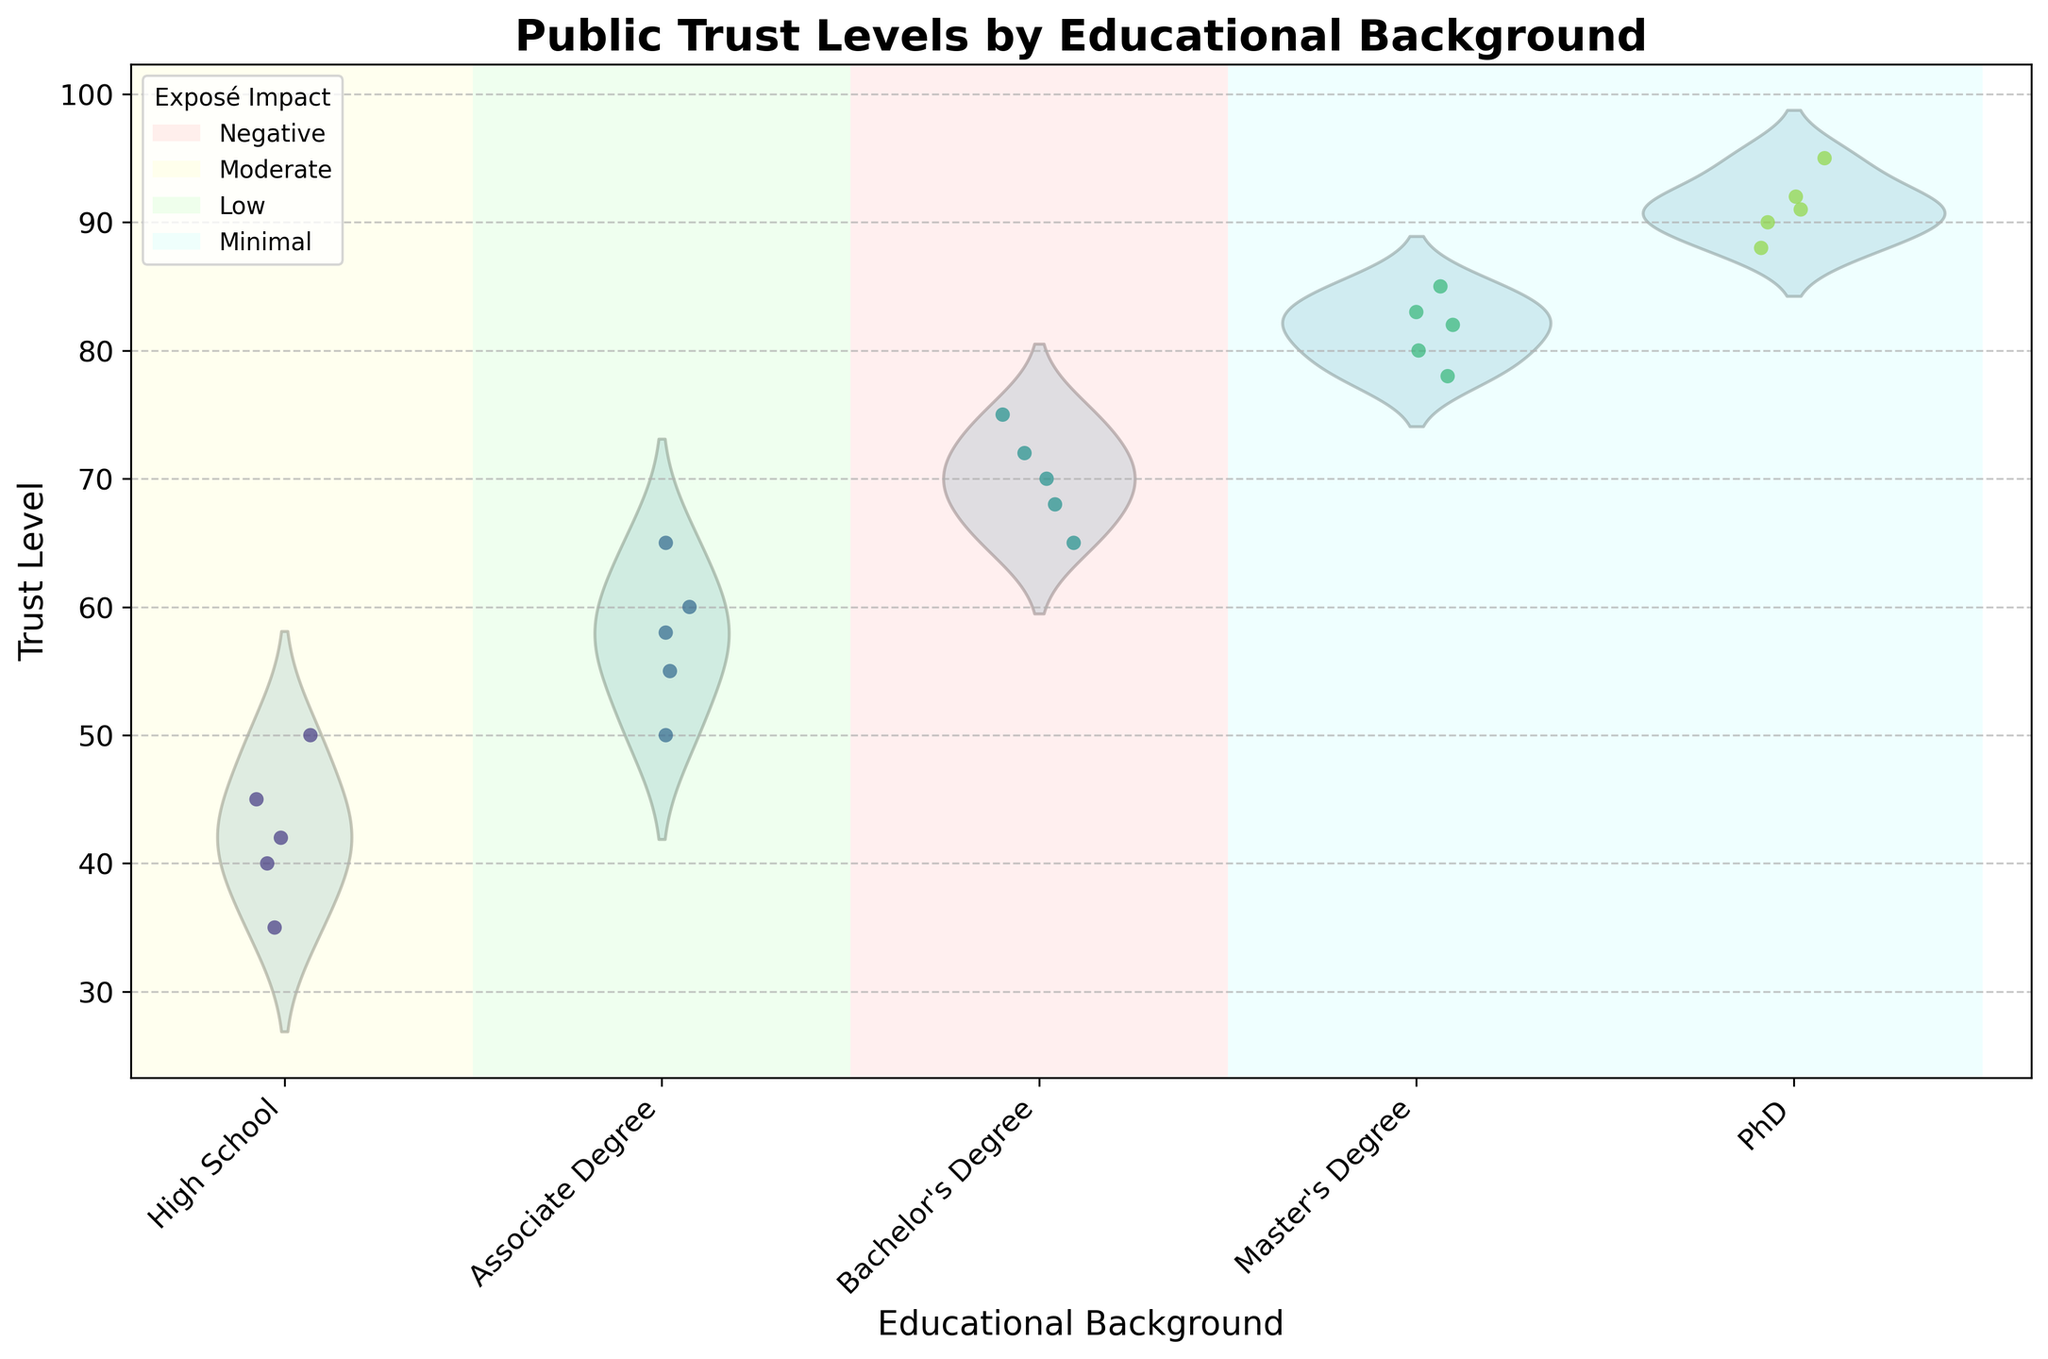What's the title of the plot? The title is shown at the top of the plot, which is "Public Trust Levels by Educational Background".
Answer: Public Trust Levels by Educational Background How many educational backgrounds are compared in the plot? The x-axis has labels for five educational backgrounds, which are "High School", "Associate Degree", "Bachelor's Degree", "Master's Degree", and "PhD".
Answer: Five Which educational background shows the highest median trust level? The highest median trust level can be inferred from the widest part of the violin plot. "PhD" background shows the highest median trust level as its widest part is higher than others on the y-axis.
Answer: PhD What color represents the impact of exposé for the "High School" group? The "High School" group is shaded in a light red color based on the plot’s background color scheme. Referring to the legend, this indicates a "Negative" impact.
Answer: Light red How does the impact of exposé differ between "Bachelor's Degree" and "High School" backgrounds? According to the shaded background colors and the legend, "High School" is affected by a "Negative" impact while "Bachelor's Degree" is affected by a "Low" impact.
Answer: High School: Negative, Bachelor's Degree: Low What is the range of trust levels for the "Master's Degree" group? The vertical spread of jittered points and the violin plot for "Master's Degree" shows that trust levels range from 78 to 85.
Answer: 78 to 85 Compare the trust levels between "Associate Degree" and "Master's Degree". Which has a higher spread? The spread is determined by the range of data points. "Associate Degree" has trust levels ranging from 50 to 65, giving a spread of 15 units. "Master's Degree" ranges from 78 to 85, giving a spread of 7 units. Therefore, "Associate Degree" has a higher spread.
Answer: Associate Degree Which group has the lowest individual trust level and what is it? Observing the lowest points in the jitter plot, the "High School" group has the lowest individual trust level at 35.
Answer: High School, 35 How many data points are available for the "PhD" category? By counting the jittered points for the "PhD" category, we find there are 5 data points.
Answer: Five What does the background color indicate in relation to the exposé impact? The background color behind each educational category indicates the exposé impact with different colors such as light red, light yellow, light green, and light blue, showcasing varying levels from "Negative" to "Minimal".
Answer: Exposé impact דירוגabets 